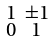<formula> <loc_0><loc_0><loc_500><loc_500>\begin{smallmatrix} 1 & \pm 1 \\ 0 & 1 \end{smallmatrix}</formula> 